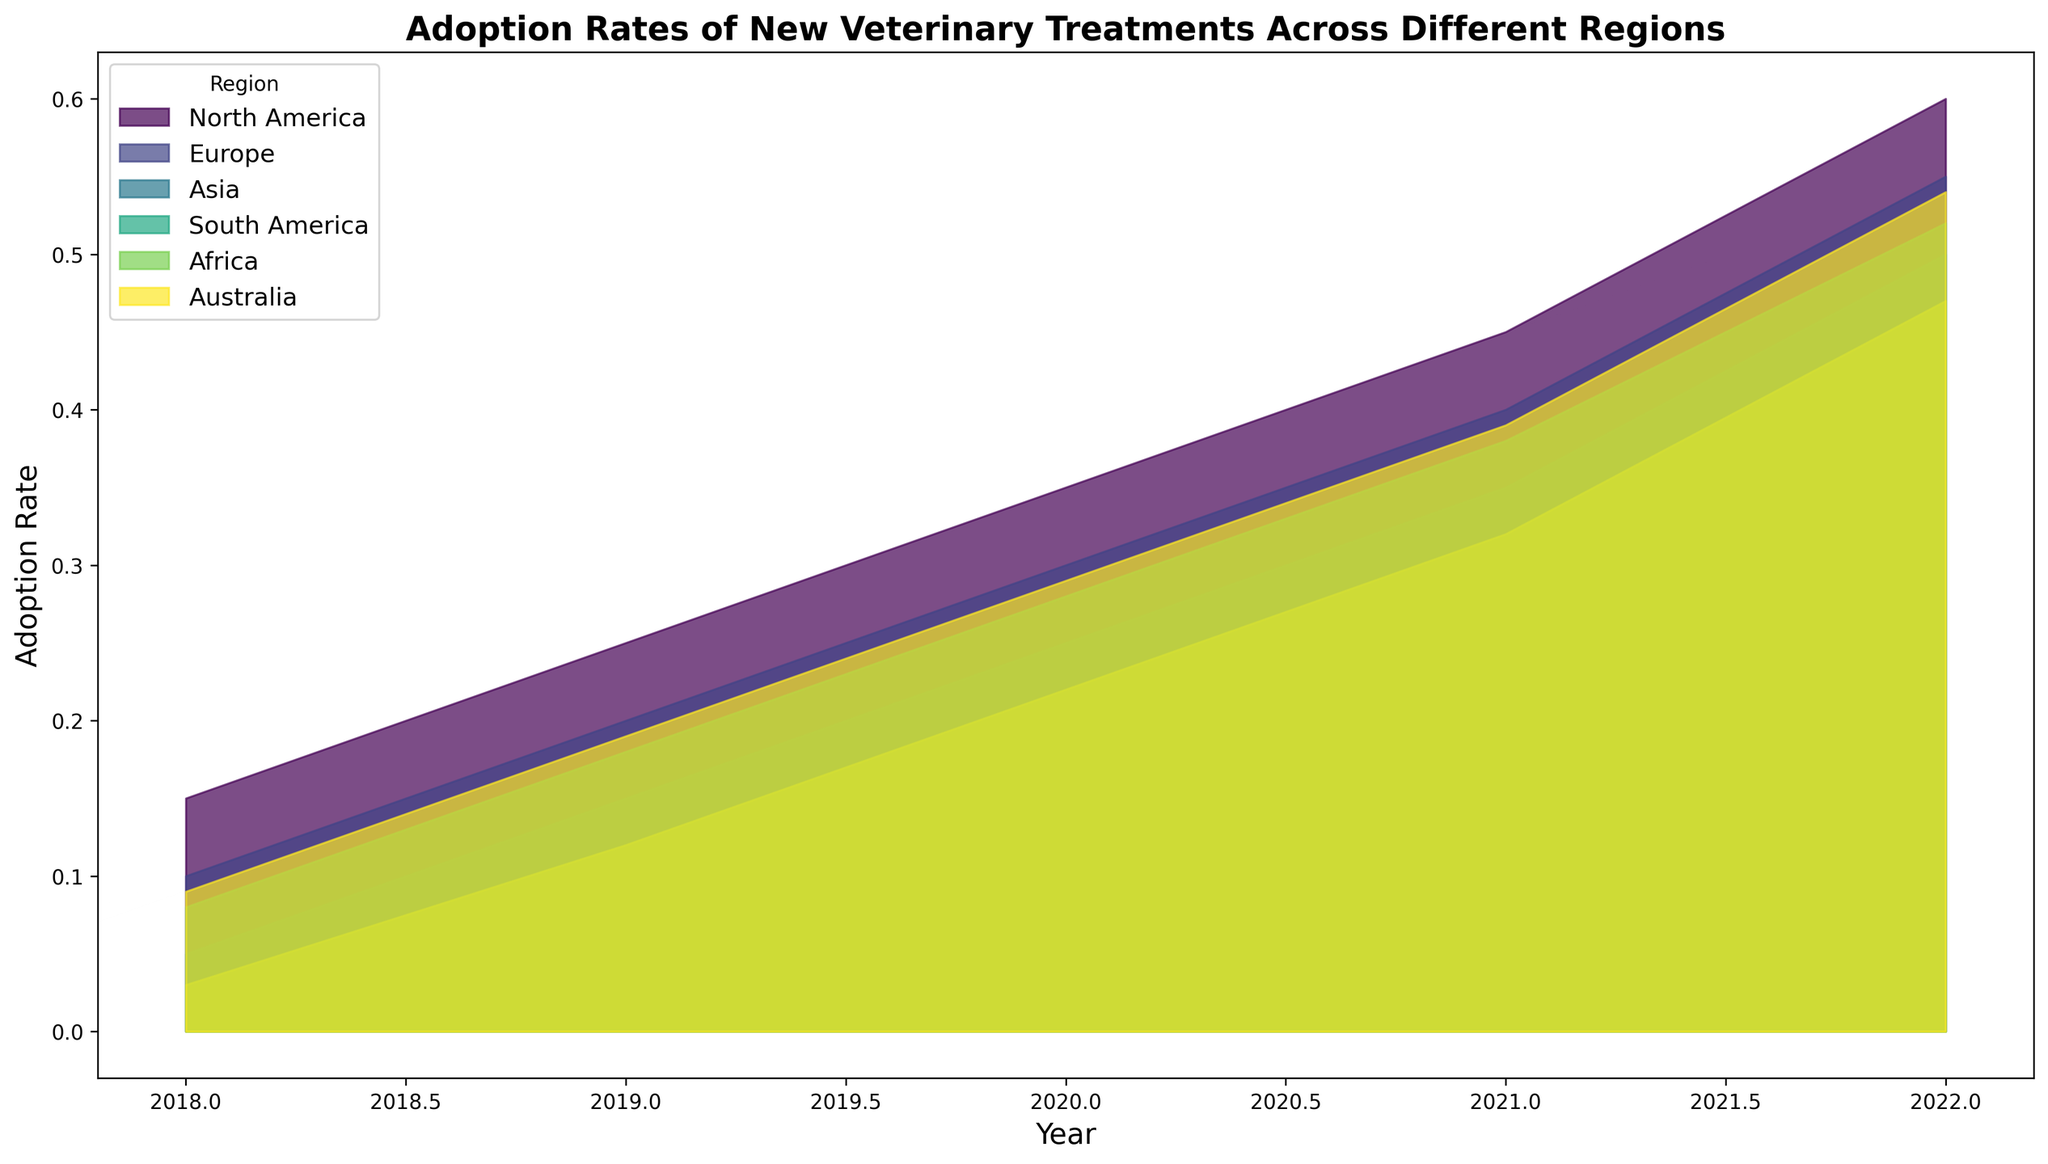Which region had the highest adoption rate in 2022? Looking at the chart, the region with the largest colored area in 2022 represents the highest adoption rate. North America has the highest adoption rate in 2022.
Answer: North America How did the adoption rate in North America change from 2018 to 2022? Identify the adoption rate for North America in 2018 and 2022. Subtract the adoption rate in 2018 (0.15) from the adoption rate in 2022 (0.60). The change is 0.60 - 0.15 = 0.45.
Answer: Increased by 0.45 Between which years did Europe experience the most significant increase in adoption rates? Compare the changes in adoption rates between consecutive years for Europe. The changes are as follows: 2018-2019 (0.10 to 0.20), 2019-2020 (0.20 to 0.30), 2020-2021 (0.30 to 0.40), and 2021-2022 (0.40 to 0.55). The most significant increase is between 2021 and 2022.
Answer: 2021 to 2022 Which region had the lowest adoption rate in 2018? Identify the smallest colored area for the year 2018. The smallest area belongs to Africa.
Answer: Africa What was the overall trend in adoption rates across all regions from 2018 to 2022? Assess the overall pattern by observing the increasing areas for all regions from 2018 to 2022. All regions exhibit an upward trend in adoption rates over the years.
Answer: Increasing trend How much did the adoption rate increase in Asia from 2019 to 2022? Identify the adoption rates for Asia in 2019 (0.15) and 2022 (0.50). Calculate the difference: 0.50 - 0.15 = 0.35.
Answer: Increased by 0.35 Comparing Europe and South America, which region had a higher adoption rate in 2020? Look at the areas for Europe and South America in 2020. Europe has an adoption rate of 0.30, while South America has 0.28. Europe had a slightly higher adoption rate.
Answer: Europe What is the difference in adoption rates between Australia and Africa in 2021? Identify the adoption rates for Australia (0.39) and Africa (0.32) in 2021. Calculate the difference: 0.39 - 0.32 = 0.07.
Answer: 0.07 Which regions achieved an adoption rate above 0.50 in 2022? Check the 2022 adoption rates for all regions. North America (0.60), Europe (0.55), Asia (0.50, just at the threshold), South America (0.52), and Australia (0.54) are above 0.50. Africa (0.47) is below 0.50.
Answer: North America, Europe, South America, Australia What was the average adoption rate for all regions in 2020? Sum the adoption rates for all regions in 2020: North America (0.35), Europe (0.30), Asia (0.25), South America (0.28), Africa (0.22), and Australia (0.29). The total is 0.35 + 0.30 + 0.25 + 0.28 + 0.22 + 0.29 = 1.69. Divide by the number of regions (6): 1.69/6 ≈ 0.28.
Answer: 0.28 